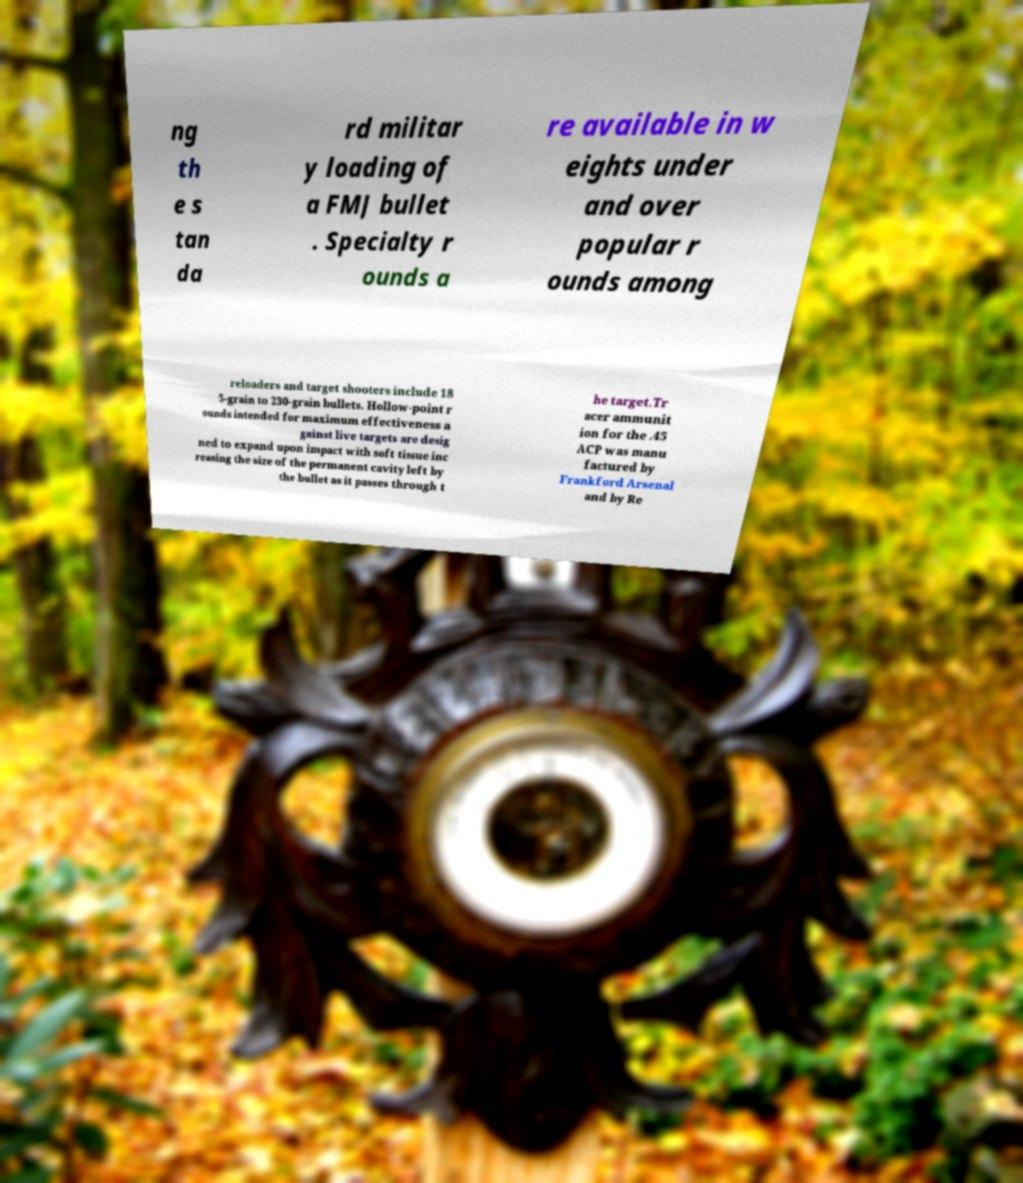Can you accurately transcribe the text from the provided image for me? ng th e s tan da rd militar y loading of a FMJ bullet . Specialty r ounds a re available in w eights under and over popular r ounds among reloaders and target shooters include 18 5-grain to 230-grain bullets. Hollow-point r ounds intended for maximum effectiveness a gainst live targets are desig ned to expand upon impact with soft tissue inc reasing the size of the permanent cavity left by the bullet as it passes through t he target.Tr acer ammunit ion for the .45 ACP was manu factured by Frankford Arsenal and by Re 